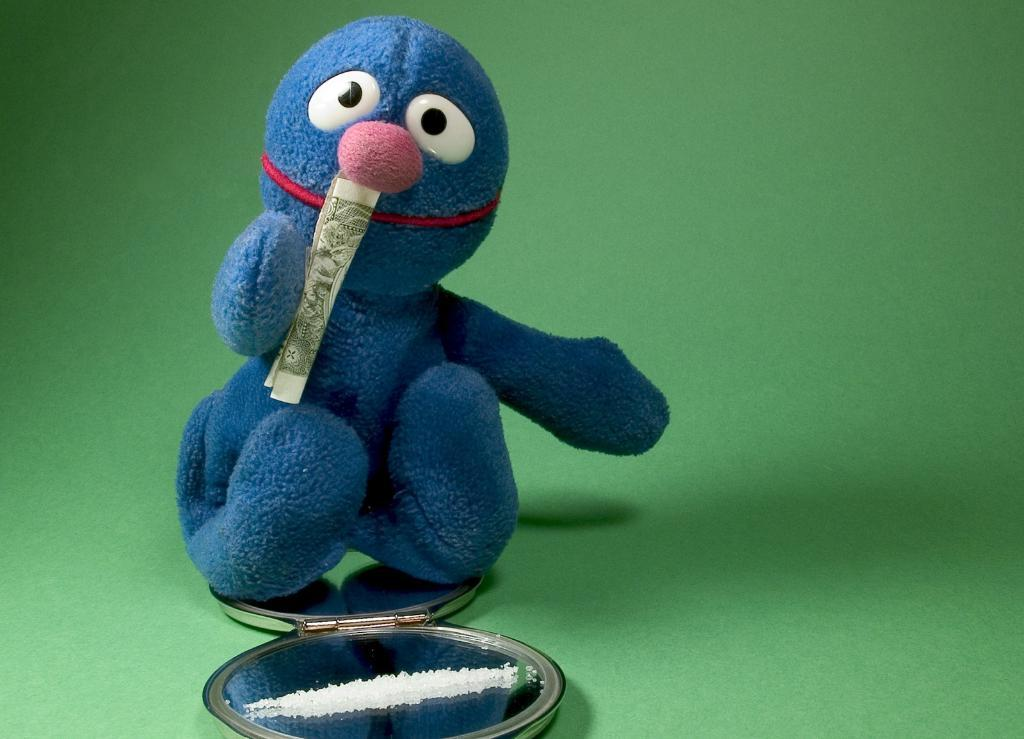What can be seen in the image that resembles a plaything? There is a toy in the image. What is placed on top of the toy? There is a paper on the toy. What is located beneath the toy? There is an object under the toy. What color is predominant in the background of the image? The background of the image is green. How does the toy shake in the image? The toy does not shake in the image; it is stationary. What type of vase is present in the image? There is no vase present in the image. 